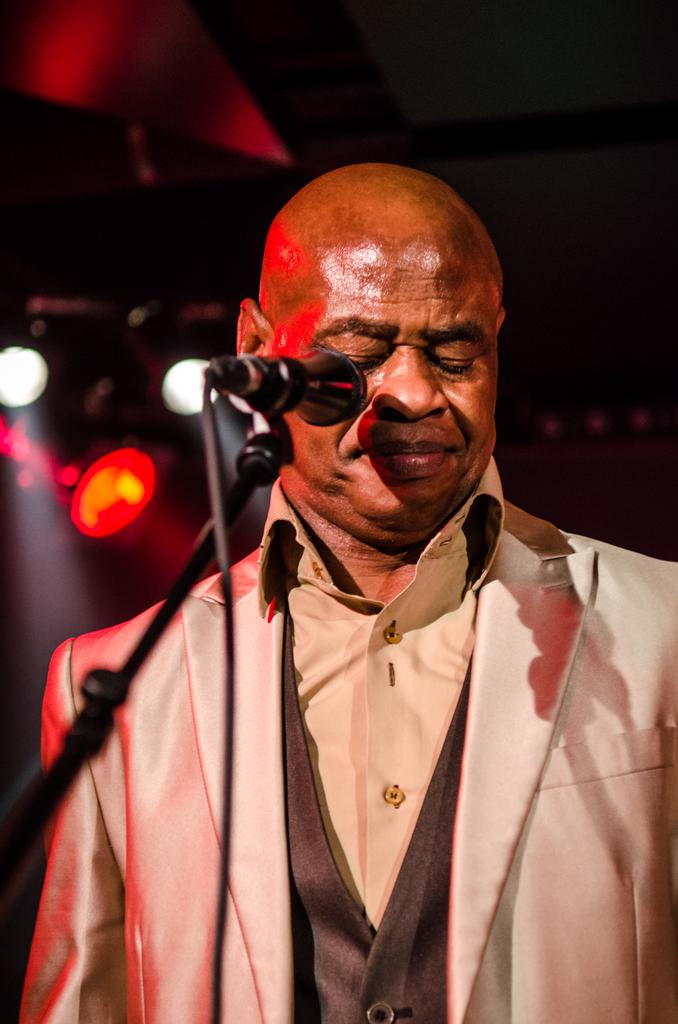What is the man in the image wearing? The man is wearing a formal suit. What object can be seen near the man in the image? There is a microphone on a stand in the image. What can be seen in the background of the image? There are lights visible in the background. How would you describe the background of the image? The background of the image is blurred. How does the man react to the earthquake in the image? There is no earthquake present in the image, so the man's reaction cannot be determined. 